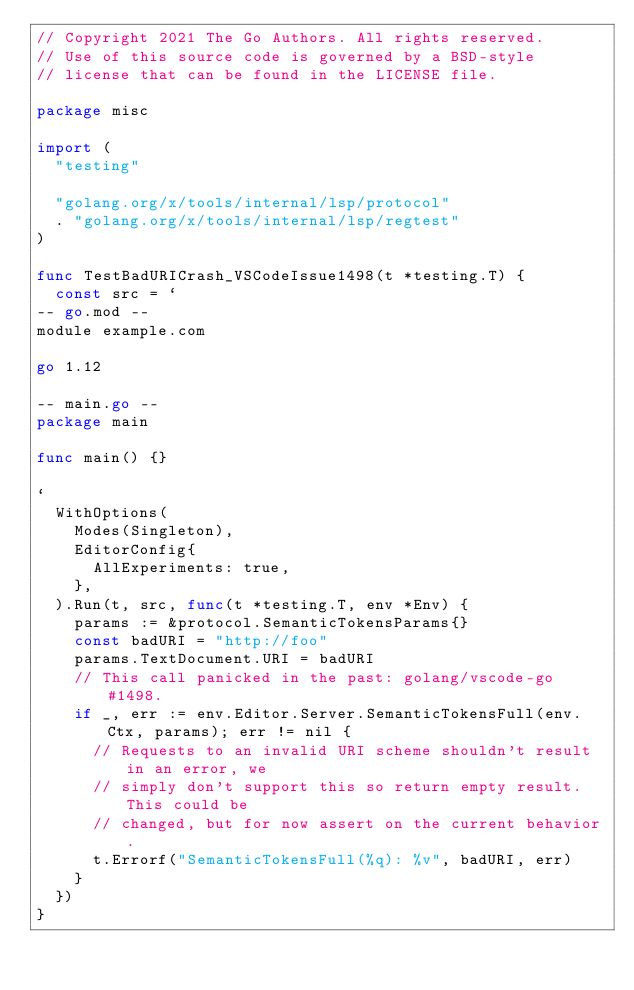<code> <loc_0><loc_0><loc_500><loc_500><_Go_>// Copyright 2021 The Go Authors. All rights reserved.
// Use of this source code is governed by a BSD-style
// license that can be found in the LICENSE file.

package misc

import (
	"testing"

	"golang.org/x/tools/internal/lsp/protocol"
	. "golang.org/x/tools/internal/lsp/regtest"
)

func TestBadURICrash_VSCodeIssue1498(t *testing.T) {
	const src = `
-- go.mod --
module example.com

go 1.12

-- main.go --
package main

func main() {}

`
	WithOptions(
		Modes(Singleton),
		EditorConfig{
			AllExperiments: true,
		},
	).Run(t, src, func(t *testing.T, env *Env) {
		params := &protocol.SemanticTokensParams{}
		const badURI = "http://foo"
		params.TextDocument.URI = badURI
		// This call panicked in the past: golang/vscode-go#1498.
		if _, err := env.Editor.Server.SemanticTokensFull(env.Ctx, params); err != nil {
			// Requests to an invalid URI scheme shouldn't result in an error, we
			// simply don't support this so return empty result. This could be
			// changed, but for now assert on the current behavior.
			t.Errorf("SemanticTokensFull(%q): %v", badURI, err)
		}
	})
}
</code> 